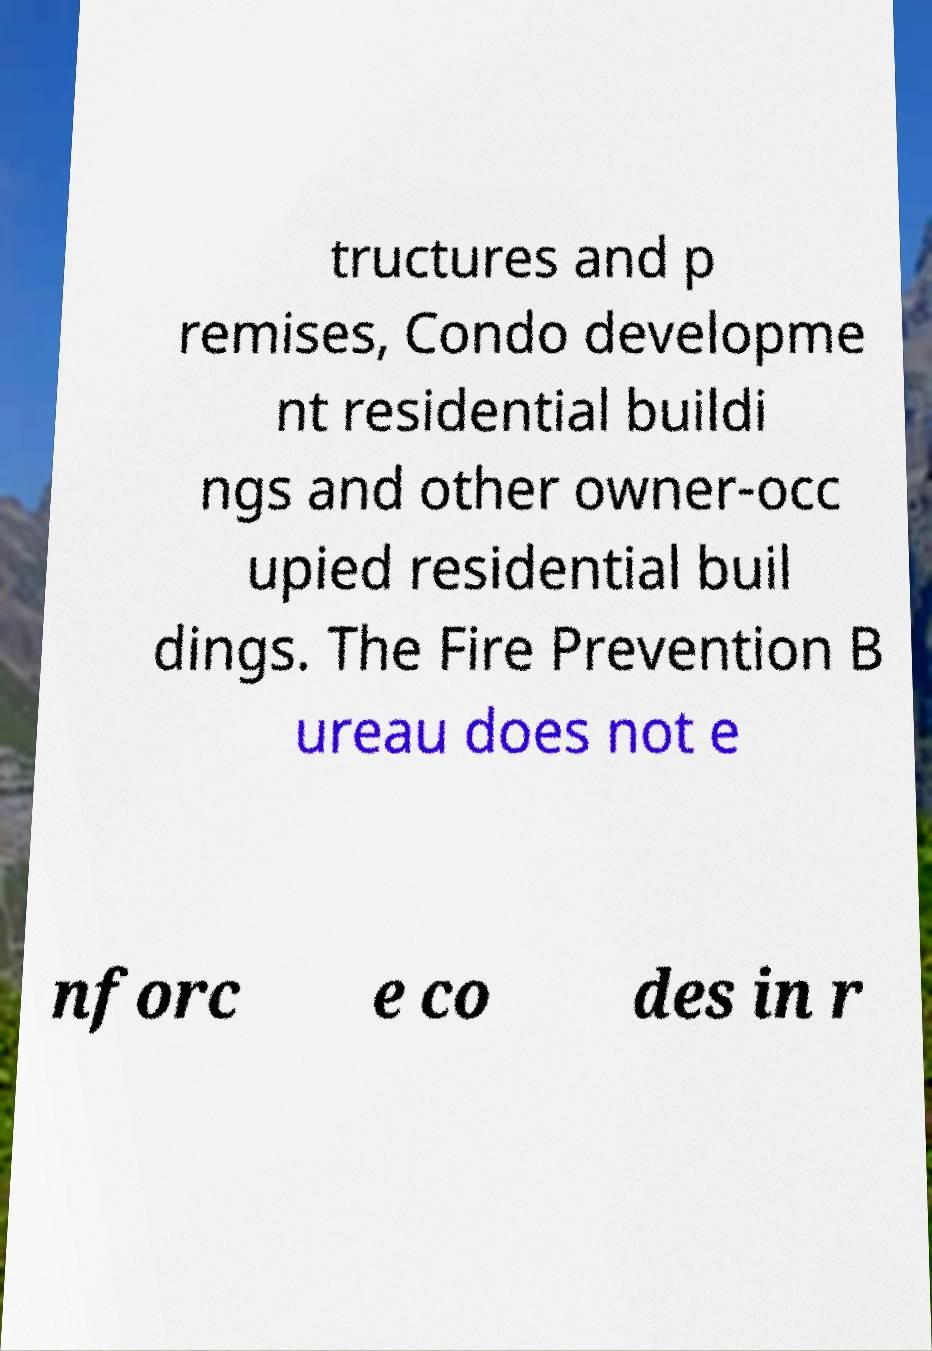Can you read and provide the text displayed in the image?This photo seems to have some interesting text. Can you extract and type it out for me? tructures and p remises, Condo developme nt residential buildi ngs and other owner-occ upied residential buil dings. The Fire Prevention B ureau does not e nforc e co des in r 